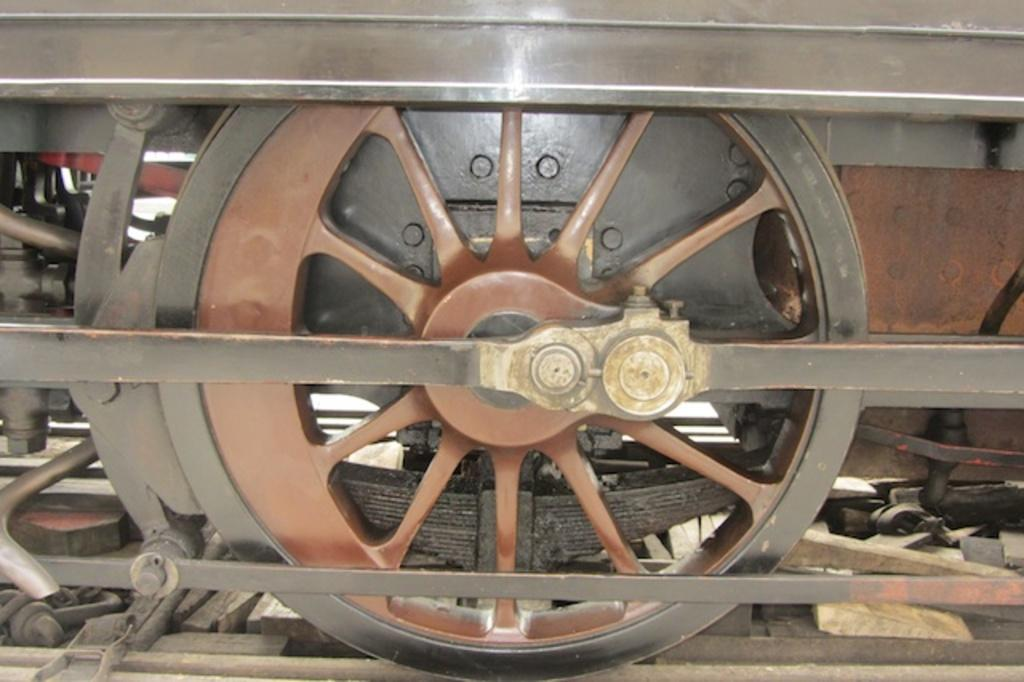What is the main subject of the image? The main subject of the image is a wheel of a train. Are there any other components of the train visible in the image? Yes, there are rods visible in the image. What type of coat is the train wearing in the image? There is no coat present in the image, as trains do not wear clothing. 